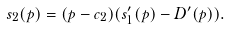Convert formula to latex. <formula><loc_0><loc_0><loc_500><loc_500>s _ { 2 } ( p ) = ( p - c _ { 2 } ) ( s _ { 1 } ^ { \prime } ( p ) - D ^ { \prime } ( p ) ) .</formula> 